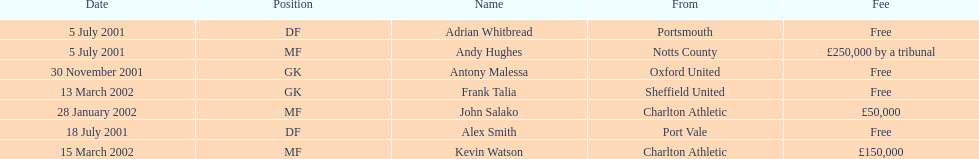Can the chart show a minimum of two different nationalities? Yes. Give me the full table as a dictionary. {'header': ['Date', 'Position', 'Name', 'From', 'Fee'], 'rows': [['5 July 2001', 'DF', 'Adrian Whitbread', 'Portsmouth', 'Free'], ['5 July 2001', 'MF', 'Andy Hughes', 'Notts County', '£250,000 by a tribunal'], ['30 November 2001', 'GK', 'Antony Malessa', 'Oxford United', 'Free'], ['13 March 2002', 'GK', 'Frank Talia', 'Sheffield United', 'Free'], ['28 January 2002', 'MF', 'John Salako', 'Charlton Athletic', '£50,000'], ['18 July 2001', 'DF', 'Alex Smith', 'Port Vale', 'Free'], ['15 March 2002', 'MF', 'Kevin Watson', 'Charlton Athletic', '£150,000']]} 